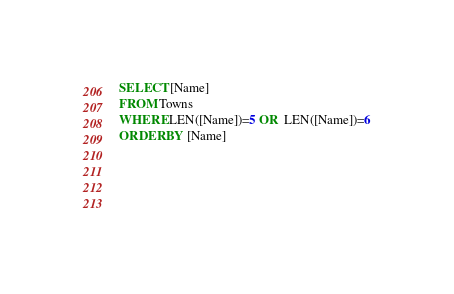Convert code to text. <code><loc_0><loc_0><loc_500><loc_500><_SQL_>SELECT [Name]
FROM Towns
WHERE LEN([Name])=5 OR  LEN([Name])=6
ORDER BY [Name]


		
	</code> 